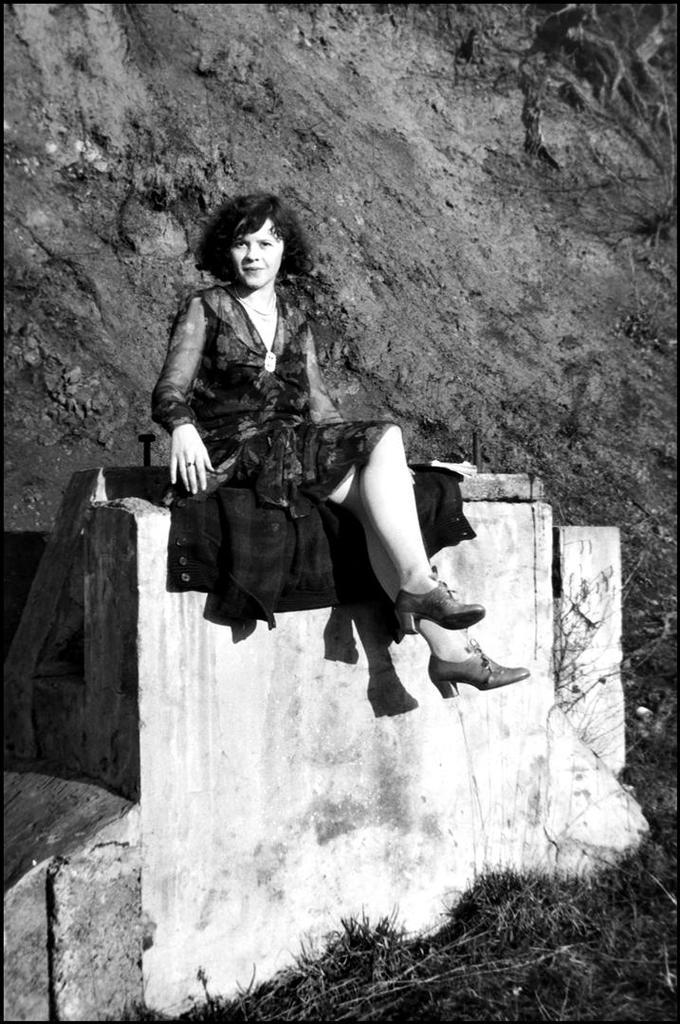What is the color scheme of the image? The image is black and white. What is the woman in the image doing? The woman is sitting on a wall in the image. What can be seen in the background of the image? There is a rock in the background of the image. How many hands does the woman have in the image? The image is black and white and does not provide enough detail to determine the number of hands the woman has. However, it is safe to assume that she has two hands, as humans typically have two hands. What type of trail can be seen in the image? There is no trail visible in the image; it only features a woman sitting on a wall and a rock in the background. 